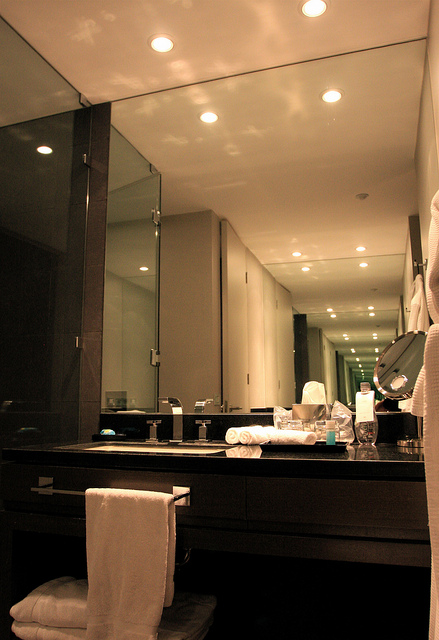Imagine if this bathroom was part of a luxury hotel suite. How might the design elements reflect the overall experience of staying there? If this bathroom were part of a luxury hotel suite, its design elements would greatly enhance the guest experience. The spaciousness created by the large mirror and glass shower would give a sense of extravagance and relaxation. The high-end sink fixtures and countertop, paired with soft, ambient lighting, would evoke a sense of sophisticated elegance. The meticulously organized towels and toiletries would provide a seamless blend of comfort and functionality. Together, these elements would reflect the hotel's commitment to offering a luxurious, stress-free stay, where every detail is curated for the guest's enjoyment and convenience. Imagine a future scenario where bathrooms are enhanced with smart technology. How might this bathroom look with these advancements? In a future scenario where bathrooms are enhanced with smart technology, this bathroom could transform into an epitome of modern convenience and luxury. The large mirror might double as a smart mirror, displaying the news, weather updates, and even personal health data while you groom. The lighting could be adjustable through voice commands or a smartphone app, allowing users to customize the brightness and color temperature according to their mood or tasks. Furthermore, the shower could feature smart controls for temperature, water flow, and even built-in speakers for a personalized experience. Automatic dispensers for soap, lotion, and towel warmers could ensure a touchless and hygienic experience. Integrating these technologies would enhance the bathroom's functionality, making daily routines more efficient and enjoyable while maintaining a stylish and sophisticated design. 